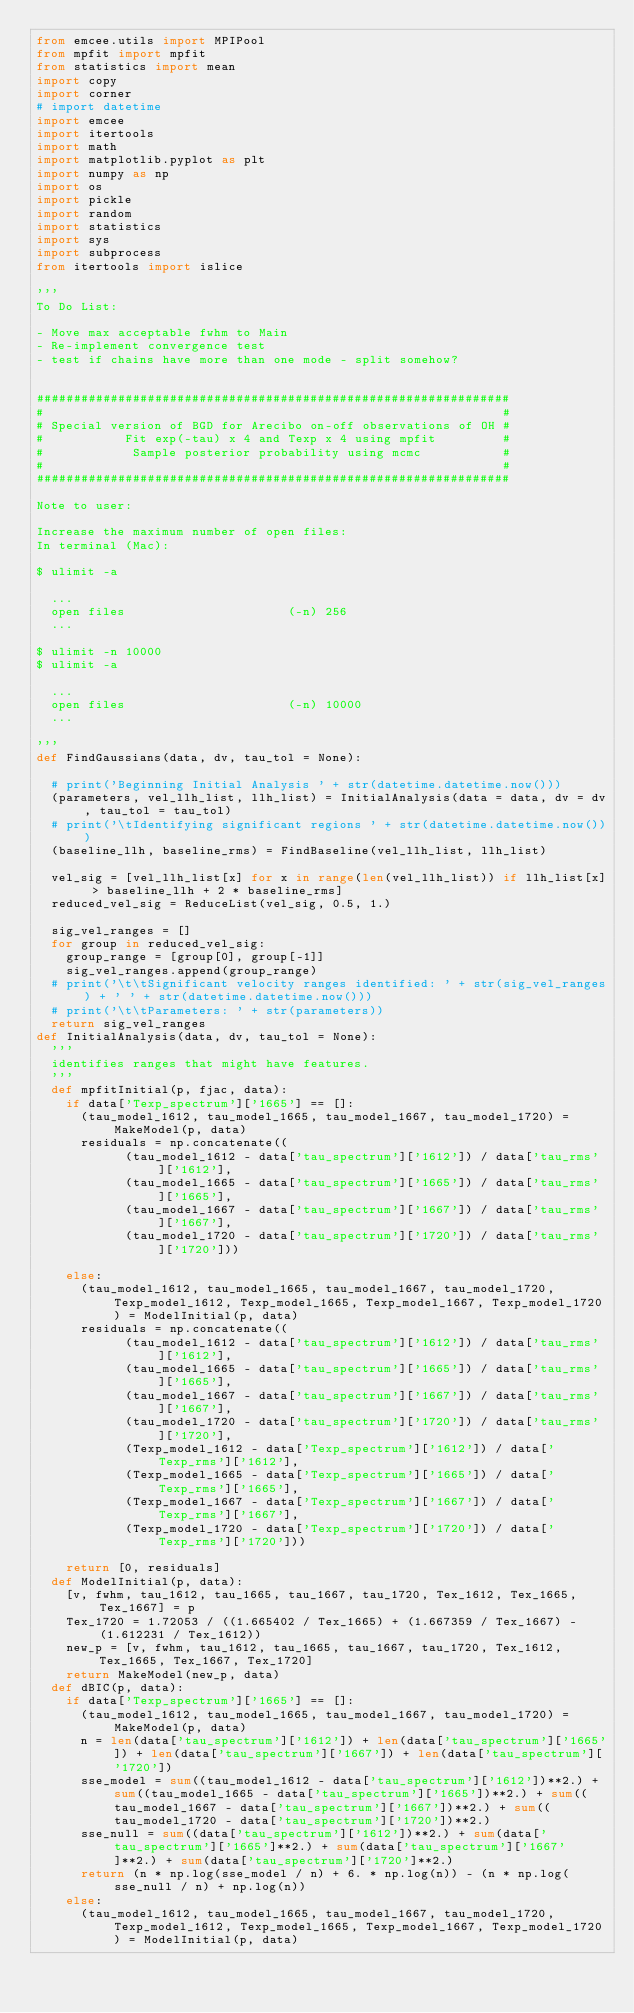Convert code to text. <code><loc_0><loc_0><loc_500><loc_500><_Python_>from emcee.utils import MPIPool
from mpfit import mpfit
from statistics import mean
import copy
import corner
# import datetime
import emcee
import itertools
import math
import matplotlib.pyplot as plt
import numpy as np
import os
import pickle
import random
import statistics
import sys
import subprocess
from itertools import islice

'''
To Do List:

- Move max acceptable fwhm to Main
- Re-implement convergence test
- test if chains have more than one mode - split somehow?


################################################################
#                                                              #
# Special version of BGD for Arecibo on-off observations of OH #
#           Fit exp(-tau) x 4 and Texp x 4 using mpfit         #
#            Sample posterior probability using mcmc           #
#                                                              #
################################################################

Note to user:

Increase the maximum number of open files:
In terminal (Mac):

$ ulimit -a

	...
	open files                      (-n) 256
	...

$ ulimit -n 10000
$ ulimit -a

	...
	open files                      (-n) 10000
	...

'''
def FindGaussians(data, dv, tau_tol = None):

	# print('Beginning Initial Analysis ' + str(datetime.datetime.now()))
	(parameters, vel_llh_list, llh_list) = InitialAnalysis(data = data, dv = dv, tau_tol = tau_tol)
	# print('\tIdentifying significant regions ' + str(datetime.datetime.now()))
	(baseline_llh, baseline_rms) = FindBaseline(vel_llh_list, llh_list)

	vel_sig = [vel_llh_list[x] for x in range(len(vel_llh_list)) if llh_list[x] > baseline_llh + 2 * baseline_rms]
	reduced_vel_sig = ReduceList(vel_sig, 0.5, 1.)

	sig_vel_ranges = []
	for group in reduced_vel_sig:
		group_range = [group[0], group[-1]]
		sig_vel_ranges.append(group_range)
	# print('\t\tSignificant velocity ranges identified: ' + str(sig_vel_ranges) + ' ' + str(datetime.datetime.now()))
	# print('\t\tParameters: ' + str(parameters))
	return sig_vel_ranges
def InitialAnalysis(data, dv, tau_tol = None):
	'''
	identifies ranges that might have features.
	'''
	def mpfitInitial(p, fjac, data):
		if data['Texp_spectrum']['1665'] == []:
			(tau_model_1612, tau_model_1665, tau_model_1667, tau_model_1720) = MakeModel(p, data)
			residuals = np.concatenate((
						(tau_model_1612 - data['tau_spectrum']['1612']) / data['tau_rms']['1612'], 
						(tau_model_1665 - data['tau_spectrum']['1665']) / data['tau_rms']['1665'], 
						(tau_model_1667 - data['tau_spectrum']['1667']) / data['tau_rms']['1667'], 
						(tau_model_1720 - data['tau_spectrum']['1720']) / data['tau_rms']['1720']))

		else:
			(tau_model_1612, tau_model_1665, tau_model_1667, tau_model_1720, Texp_model_1612, Texp_model_1665, Texp_model_1667, Texp_model_1720) = ModelInitial(p, data)
			residuals = np.concatenate((
						(tau_model_1612 - data['tau_spectrum']['1612']) / data['tau_rms']['1612'], 
						(tau_model_1665 - data['tau_spectrum']['1665']) / data['tau_rms']['1665'], 
						(tau_model_1667 - data['tau_spectrum']['1667']) / data['tau_rms']['1667'], 
						(tau_model_1720 - data['tau_spectrum']['1720']) / data['tau_rms']['1720'], 
						(Texp_model_1612 - data['Texp_spectrum']['1612']) / data['Texp_rms']['1612'], 
						(Texp_model_1665 - data['Texp_spectrum']['1665']) / data['Texp_rms']['1665'], 
						(Texp_model_1667 - data['Texp_spectrum']['1667']) / data['Texp_rms']['1667'], 
						(Texp_model_1720 - data['Texp_spectrum']['1720']) / data['Texp_rms']['1720'])) 

		return [0, residuals]
	def ModelInitial(p, data):
		[v, fwhm, tau_1612, tau_1665, tau_1667, tau_1720, Tex_1612, Tex_1665, Tex_1667] = p
		Tex_1720 = 1.72053 / ((1.665402 / Tex_1665) + (1.667359 / Tex_1667) - (1.612231 / Tex_1612))
		new_p = [v, fwhm, tau_1612, tau_1665, tau_1667, tau_1720, Tex_1612, Tex_1665, Tex_1667, Tex_1720]
		return MakeModel(new_p, data)
	def dBIC(p, data):
		if data['Texp_spectrum']['1665'] == []:
			(tau_model_1612, tau_model_1665, tau_model_1667, tau_model_1720) = MakeModel(p, data)
			n = len(data['tau_spectrum']['1612']) + len(data['tau_spectrum']['1665']) + len(data['tau_spectrum']['1667']) + len(data['tau_spectrum']['1720'])
			sse_model = sum((tau_model_1612 - data['tau_spectrum']['1612'])**2.) + sum((tau_model_1665 - data['tau_spectrum']['1665'])**2.) + sum((tau_model_1667 - data['tau_spectrum']['1667'])**2.) + sum((tau_model_1720 - data['tau_spectrum']['1720'])**2.)
			sse_null = sum((data['tau_spectrum']['1612'])**2.) + sum(data['tau_spectrum']['1665']**2.) + sum(data['tau_spectrum']['1667']**2.) + sum(data['tau_spectrum']['1720']**2.)
			return (n * np.log(sse_model / n) + 6. * np.log(n)) - (n * np.log(sse_null / n) + np.log(n))
		else:
			(tau_model_1612, tau_model_1665, tau_model_1667, tau_model_1720, Texp_model_1612, Texp_model_1665, Texp_model_1667, Texp_model_1720) = ModelInitial(p, data)</code> 